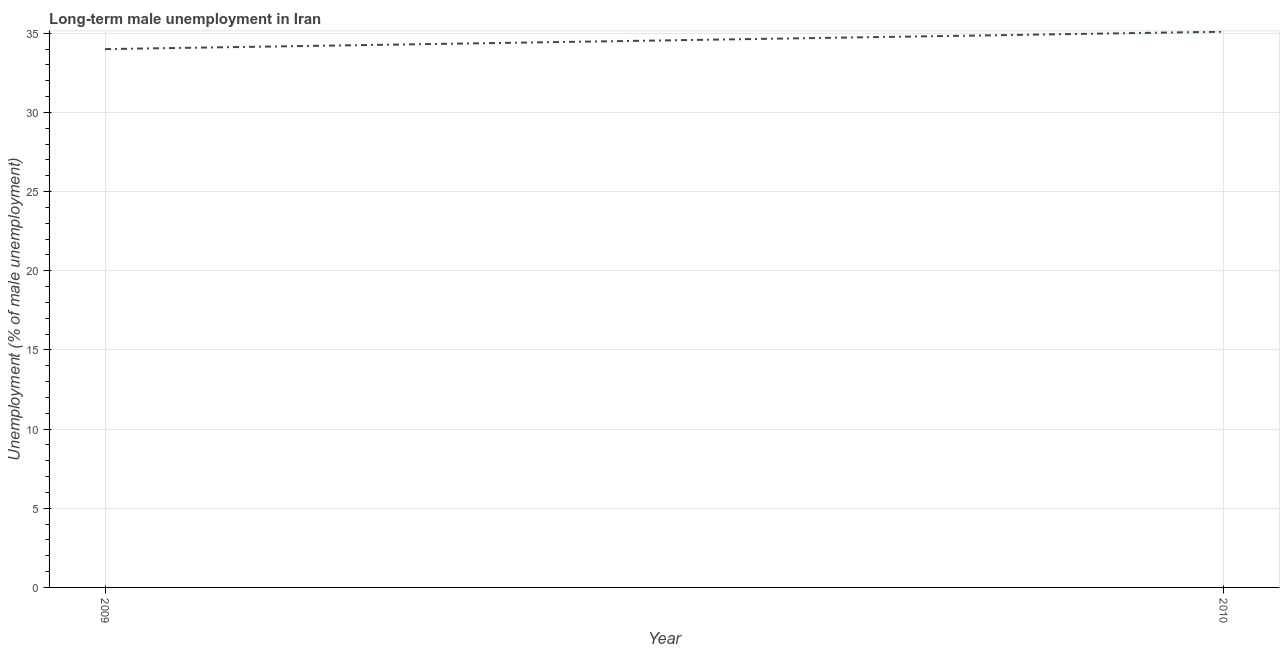Across all years, what is the maximum long-term male unemployment?
Keep it short and to the point. 35.1. In which year was the long-term male unemployment maximum?
Your answer should be very brief. 2010. What is the sum of the long-term male unemployment?
Provide a succinct answer. 69.1. What is the difference between the long-term male unemployment in 2009 and 2010?
Your answer should be very brief. -1.1. What is the average long-term male unemployment per year?
Offer a very short reply. 34.55. What is the median long-term male unemployment?
Your answer should be compact. 34.55. In how many years, is the long-term male unemployment greater than 1 %?
Make the answer very short. 2. What is the ratio of the long-term male unemployment in 2009 to that in 2010?
Give a very brief answer. 0.97. In how many years, is the long-term male unemployment greater than the average long-term male unemployment taken over all years?
Your response must be concise. 1. Does the long-term male unemployment monotonically increase over the years?
Keep it short and to the point. Yes. How many lines are there?
Ensure brevity in your answer.  1. How many years are there in the graph?
Make the answer very short. 2. What is the difference between two consecutive major ticks on the Y-axis?
Your answer should be very brief. 5. Are the values on the major ticks of Y-axis written in scientific E-notation?
Your response must be concise. No. Does the graph contain any zero values?
Your answer should be very brief. No. What is the title of the graph?
Your answer should be very brief. Long-term male unemployment in Iran. What is the label or title of the Y-axis?
Keep it short and to the point. Unemployment (% of male unemployment). What is the Unemployment (% of male unemployment) of 2010?
Offer a terse response. 35.1. What is the difference between the Unemployment (% of male unemployment) in 2009 and 2010?
Your answer should be very brief. -1.1. 